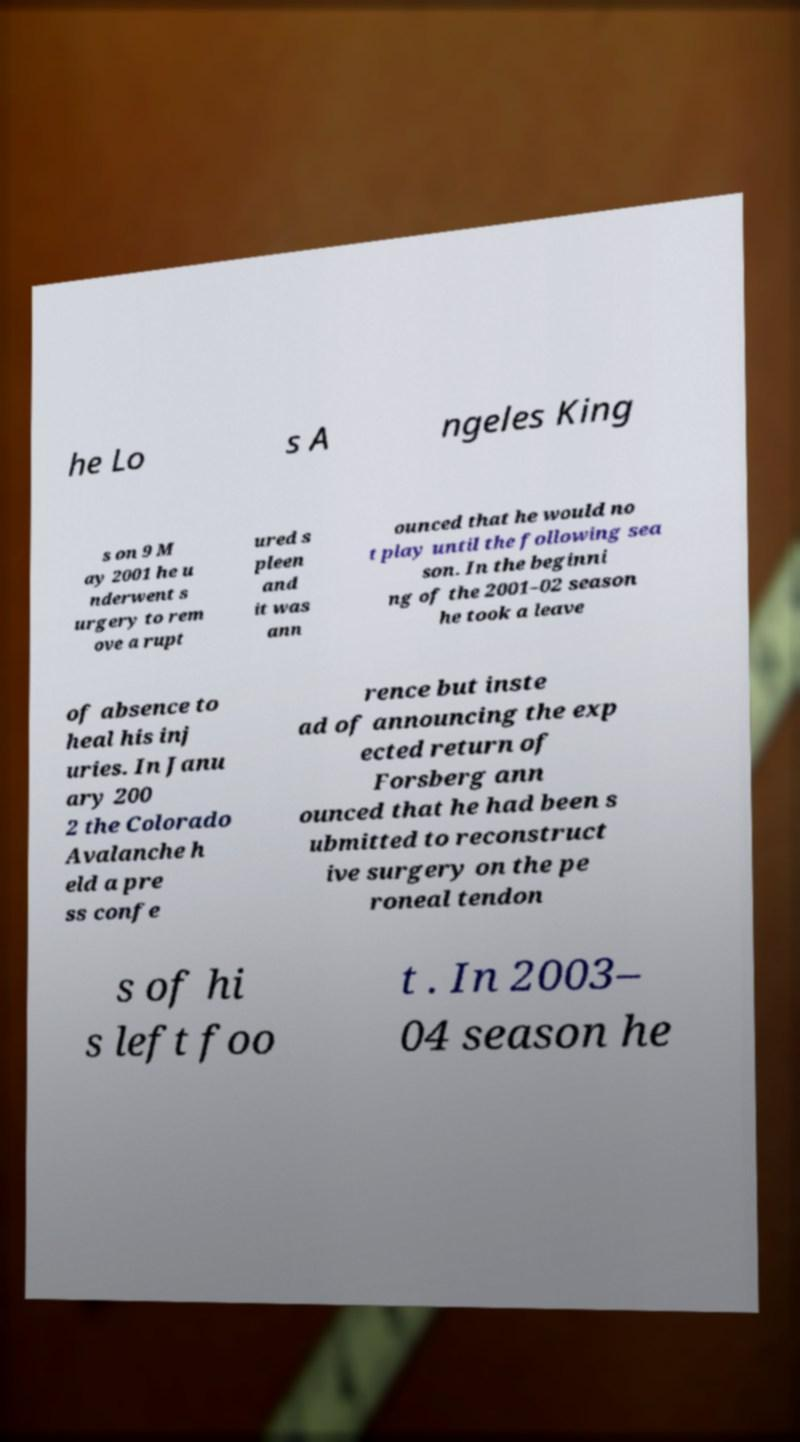I need the written content from this picture converted into text. Can you do that? he Lo s A ngeles King s on 9 M ay 2001 he u nderwent s urgery to rem ove a rupt ured s pleen and it was ann ounced that he would no t play until the following sea son. In the beginni ng of the 2001–02 season he took a leave of absence to heal his inj uries. In Janu ary 200 2 the Colorado Avalanche h eld a pre ss confe rence but inste ad of announcing the exp ected return of Forsberg ann ounced that he had been s ubmitted to reconstruct ive surgery on the pe roneal tendon s of hi s left foo t . In 2003– 04 season he 